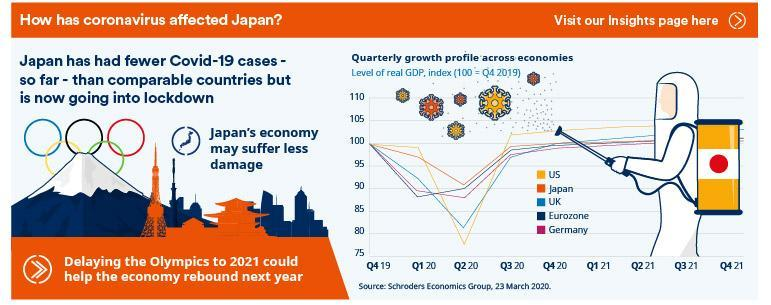Which country sees smallest fall in GDP in Q2 20?
Answer the question with a short phrase. Japan What can help rebound of Japan's economy ? Delaying the Olympics to 2021 Which country has lowest GDP in Q2 20? US Which country has second lowest GDP in Q2 20? UK 